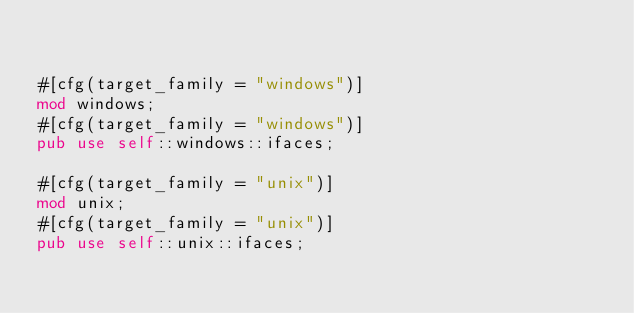<code> <loc_0><loc_0><loc_500><loc_500><_Rust_>

#[cfg(target_family = "windows")]
mod windows;
#[cfg(target_family = "windows")]
pub use self::windows::ifaces;

#[cfg(target_family = "unix")]
mod unix;
#[cfg(target_family = "unix")]
pub use self::unix::ifaces;
</code> 